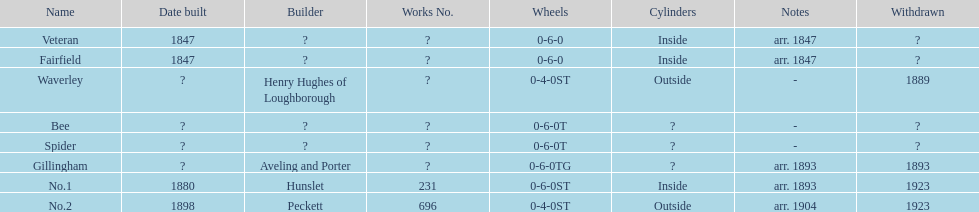Can you provide the names related to alderney railway? Veteran, Fairfield, Waverley, Bee, Spider, Gillingham, No.1, No.2. When was the farfield's construction completed? 1847. What other buildings were completed in that year? Veteran. 